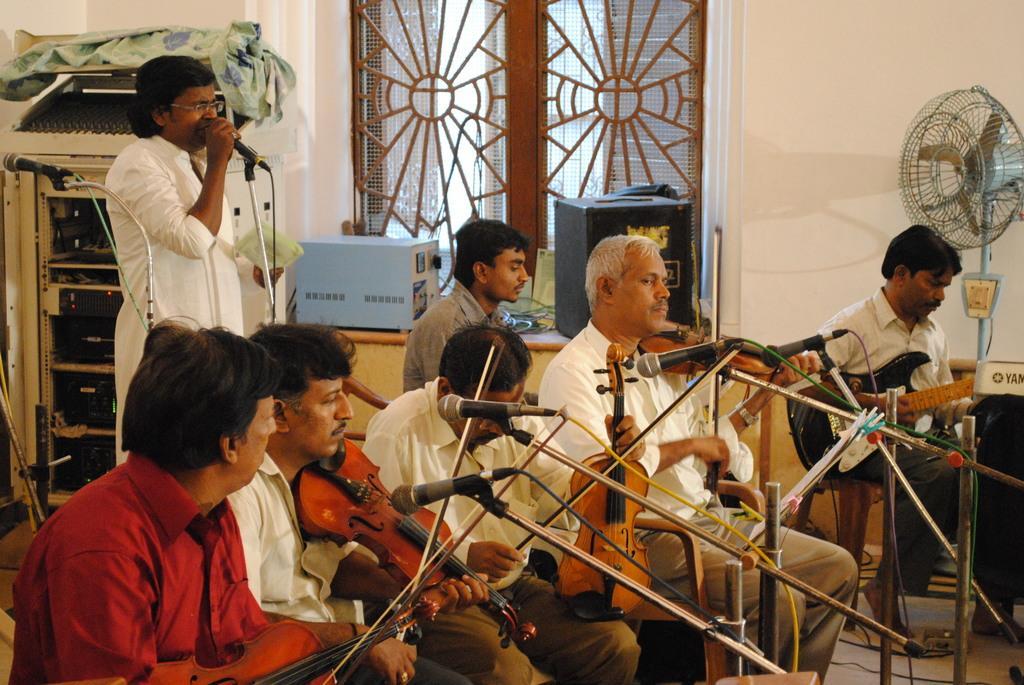In one or two sentences, can you explain what this image depicts? This picture is taken in the room, There are some sitting on the chairs and they are holding some music instruments and there are some microphone which are in black color, In the background there is a man standing and he is singing in the microphone and there is a wall which is in white color and there is a window in brown color. 